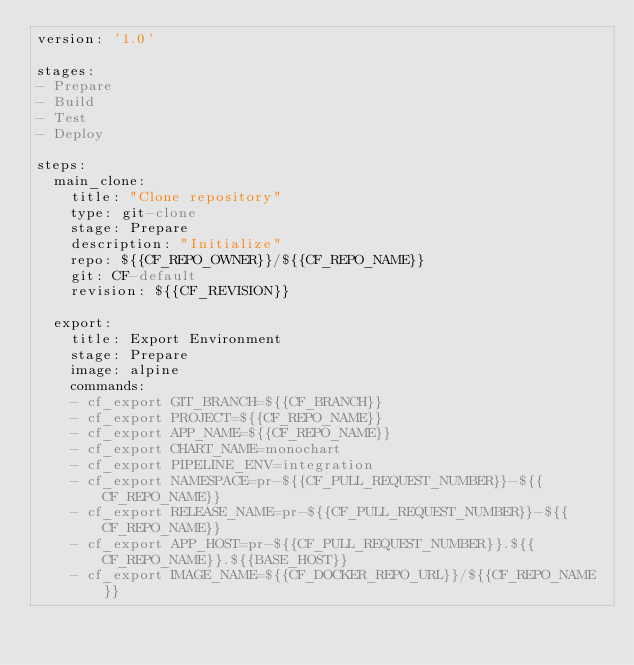Convert code to text. <code><loc_0><loc_0><loc_500><loc_500><_YAML_>version: '1.0'

stages:
- Prepare
- Build
- Test
- Deploy

steps:
  main_clone:
    title: "Clone repository"
    type: git-clone
    stage: Prepare
    description: "Initialize"
    repo: ${{CF_REPO_OWNER}}/${{CF_REPO_NAME}}
    git: CF-default
    revision: ${{CF_REVISION}}

  export:
    title: Export Environment
    stage: Prepare
    image: alpine
    commands:
    - cf_export GIT_BRANCH=${{CF_BRANCH}}
    - cf_export PROJECT=${{CF_REPO_NAME}}
    - cf_export APP_NAME=${{CF_REPO_NAME}}
    - cf_export CHART_NAME=monochart
    - cf_export PIPELINE_ENV=integration
    - cf_export NAMESPACE=pr-${{CF_PULL_REQUEST_NUMBER}}-${{CF_REPO_NAME}}
    - cf_export RELEASE_NAME=pr-${{CF_PULL_REQUEST_NUMBER}}-${{CF_REPO_NAME}}
    - cf_export APP_HOST=pr-${{CF_PULL_REQUEST_NUMBER}}.${{CF_REPO_NAME}}.${{BASE_HOST}}
    - cf_export IMAGE_NAME=${{CF_DOCKER_REPO_URL}}/${{CF_REPO_NAME}}</code> 